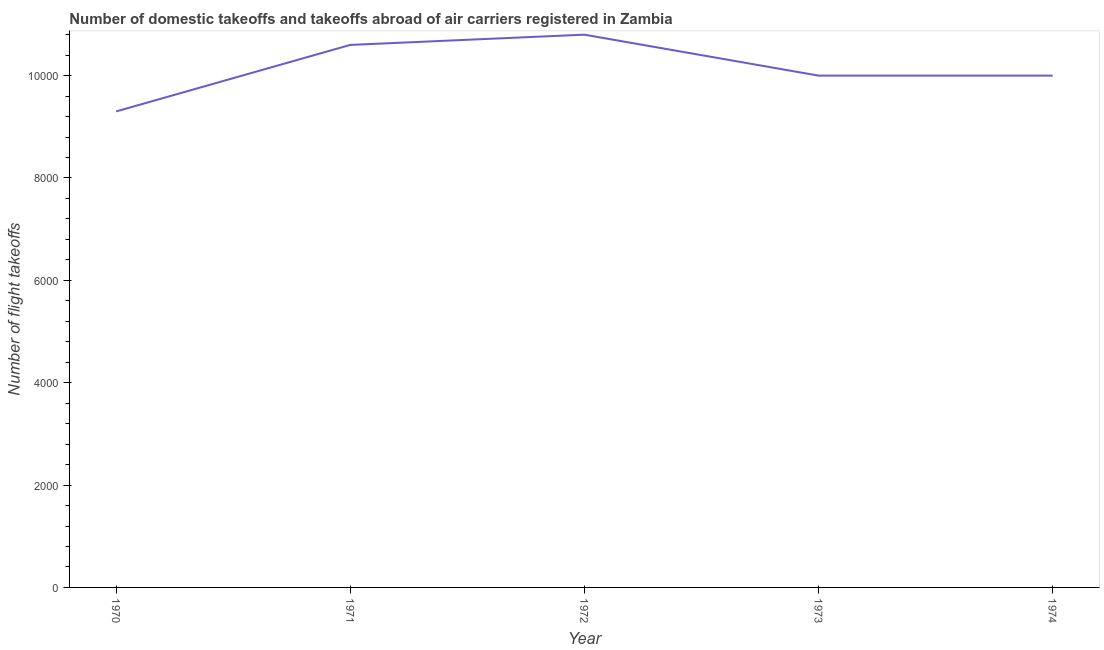What is the number of flight takeoffs in 1971?
Provide a short and direct response. 1.06e+04. Across all years, what is the maximum number of flight takeoffs?
Provide a short and direct response. 1.08e+04. Across all years, what is the minimum number of flight takeoffs?
Ensure brevity in your answer.  9300. In which year was the number of flight takeoffs minimum?
Your answer should be very brief. 1970. What is the sum of the number of flight takeoffs?
Your answer should be very brief. 5.07e+04. What is the difference between the number of flight takeoffs in 1972 and 1973?
Your response must be concise. 800. What is the average number of flight takeoffs per year?
Offer a very short reply. 1.01e+04. What is the median number of flight takeoffs?
Make the answer very short. 10000. Do a majority of the years between 1972 and 1970 (inclusive) have number of flight takeoffs greater than 7200 ?
Keep it short and to the point. No. What is the ratio of the number of flight takeoffs in 1971 to that in 1973?
Your answer should be very brief. 1.06. Is the number of flight takeoffs in 1970 less than that in 1971?
Your answer should be very brief. Yes. Is the sum of the number of flight takeoffs in 1970 and 1973 greater than the maximum number of flight takeoffs across all years?
Offer a very short reply. Yes. What is the difference between the highest and the lowest number of flight takeoffs?
Your response must be concise. 1500. Are the values on the major ticks of Y-axis written in scientific E-notation?
Your answer should be compact. No. What is the title of the graph?
Your answer should be very brief. Number of domestic takeoffs and takeoffs abroad of air carriers registered in Zambia. What is the label or title of the Y-axis?
Offer a terse response. Number of flight takeoffs. What is the Number of flight takeoffs of 1970?
Provide a succinct answer. 9300. What is the Number of flight takeoffs of 1971?
Provide a succinct answer. 1.06e+04. What is the Number of flight takeoffs of 1972?
Make the answer very short. 1.08e+04. What is the Number of flight takeoffs in 1973?
Your answer should be compact. 10000. What is the difference between the Number of flight takeoffs in 1970 and 1971?
Provide a succinct answer. -1300. What is the difference between the Number of flight takeoffs in 1970 and 1972?
Your answer should be very brief. -1500. What is the difference between the Number of flight takeoffs in 1970 and 1973?
Provide a succinct answer. -700. What is the difference between the Number of flight takeoffs in 1970 and 1974?
Offer a very short reply. -700. What is the difference between the Number of flight takeoffs in 1971 and 1972?
Your answer should be compact. -200. What is the difference between the Number of flight takeoffs in 1971 and 1973?
Give a very brief answer. 600. What is the difference between the Number of flight takeoffs in 1971 and 1974?
Give a very brief answer. 600. What is the difference between the Number of flight takeoffs in 1972 and 1973?
Make the answer very short. 800. What is the difference between the Number of flight takeoffs in 1972 and 1974?
Make the answer very short. 800. What is the difference between the Number of flight takeoffs in 1973 and 1974?
Your answer should be compact. 0. What is the ratio of the Number of flight takeoffs in 1970 to that in 1971?
Your answer should be compact. 0.88. What is the ratio of the Number of flight takeoffs in 1970 to that in 1972?
Ensure brevity in your answer.  0.86. What is the ratio of the Number of flight takeoffs in 1970 to that in 1973?
Ensure brevity in your answer.  0.93. What is the ratio of the Number of flight takeoffs in 1971 to that in 1973?
Your answer should be compact. 1.06. What is the ratio of the Number of flight takeoffs in 1971 to that in 1974?
Ensure brevity in your answer.  1.06. 